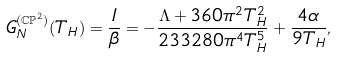Convert formula to latex. <formula><loc_0><loc_0><loc_500><loc_500>G _ { N } ^ { ( \mathbb { C P } ^ { 2 } ) } ( T _ { H } ) = \frac { I } { \beta } = - \frac { \Lambda + 3 6 0 \pi ^ { 2 } T _ { H } ^ { 2 } } { 2 3 3 2 8 0 \pi ^ { 4 } T _ { H } ^ { 5 } } + \frac { 4 \alpha } { 9 T _ { H } } ,</formula> 